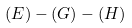Convert formula to latex. <formula><loc_0><loc_0><loc_500><loc_500>( E ) - ( G ) - ( H )</formula> 